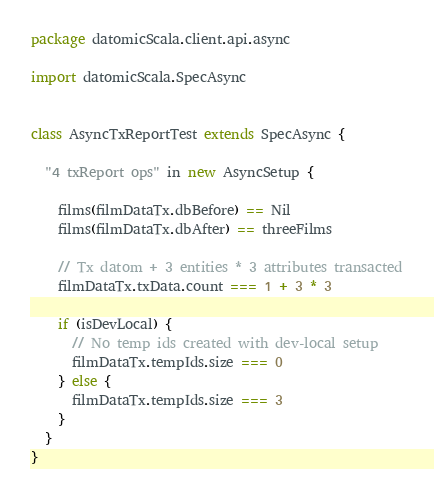<code> <loc_0><loc_0><loc_500><loc_500><_Scala_>package datomicScala.client.api.async

import datomicScala.SpecAsync


class AsyncTxReportTest extends SpecAsync {

  "4 txReport ops" in new AsyncSetup {

    films(filmDataTx.dbBefore) == Nil
    films(filmDataTx.dbAfter) == threeFilms

    // Tx datom + 3 entities * 3 attributes transacted
    filmDataTx.txData.count === 1 + 3 * 3

    if (isDevLocal) {
      // No temp ids created with dev-local setup
      filmDataTx.tempIds.size === 0
    } else {
      filmDataTx.tempIds.size === 3
    }
  }
}</code> 